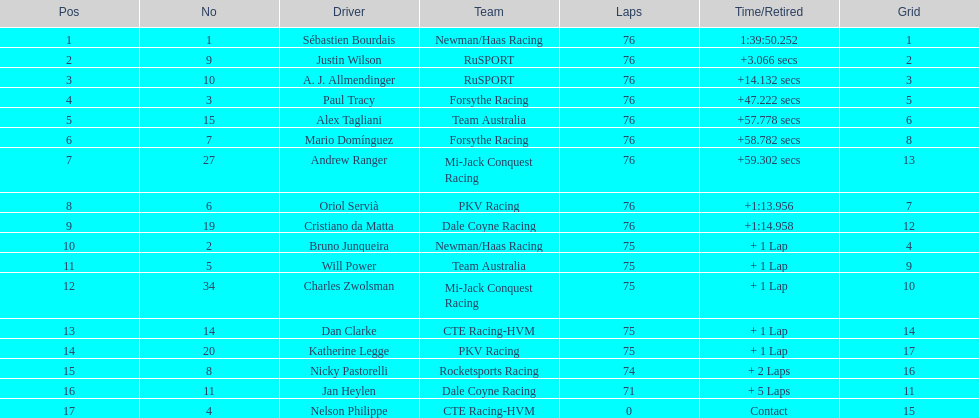Which driver earned the least amount of points. Nelson Philippe. 